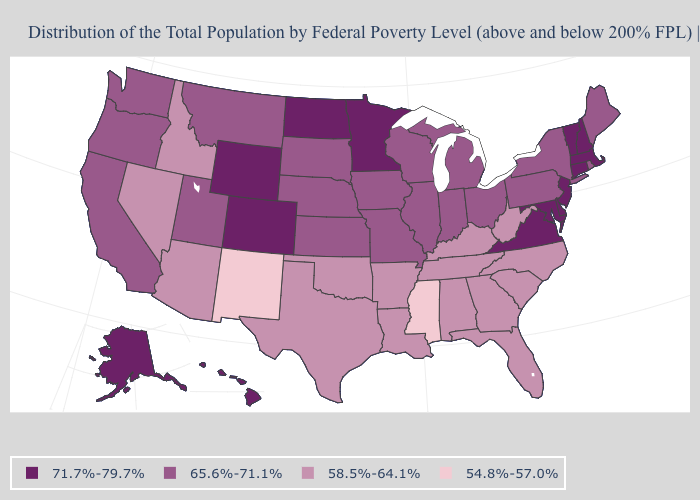Which states hav the highest value in the West?
Write a very short answer. Alaska, Colorado, Hawaii, Wyoming. What is the lowest value in states that border North Dakota?
Quick response, please. 65.6%-71.1%. What is the value of Wisconsin?
Quick response, please. 65.6%-71.1%. What is the value of California?
Write a very short answer. 65.6%-71.1%. Is the legend a continuous bar?
Short answer required. No. Which states have the lowest value in the MidWest?
Write a very short answer. Illinois, Indiana, Iowa, Kansas, Michigan, Missouri, Nebraska, Ohio, South Dakota, Wisconsin. What is the value of New York?
Keep it brief. 65.6%-71.1%. What is the value of Rhode Island?
Short answer required. 65.6%-71.1%. Name the states that have a value in the range 54.8%-57.0%?
Answer briefly. Mississippi, New Mexico. Among the states that border Tennessee , does Mississippi have the lowest value?
Write a very short answer. Yes. Which states have the lowest value in the USA?
Give a very brief answer. Mississippi, New Mexico. Does Pennsylvania have the lowest value in the Northeast?
Quick response, please. Yes. What is the lowest value in states that border New York?
Answer briefly. 65.6%-71.1%. Does Wyoming have the highest value in the West?
Keep it brief. Yes. What is the value of Colorado?
Quick response, please. 71.7%-79.7%. 